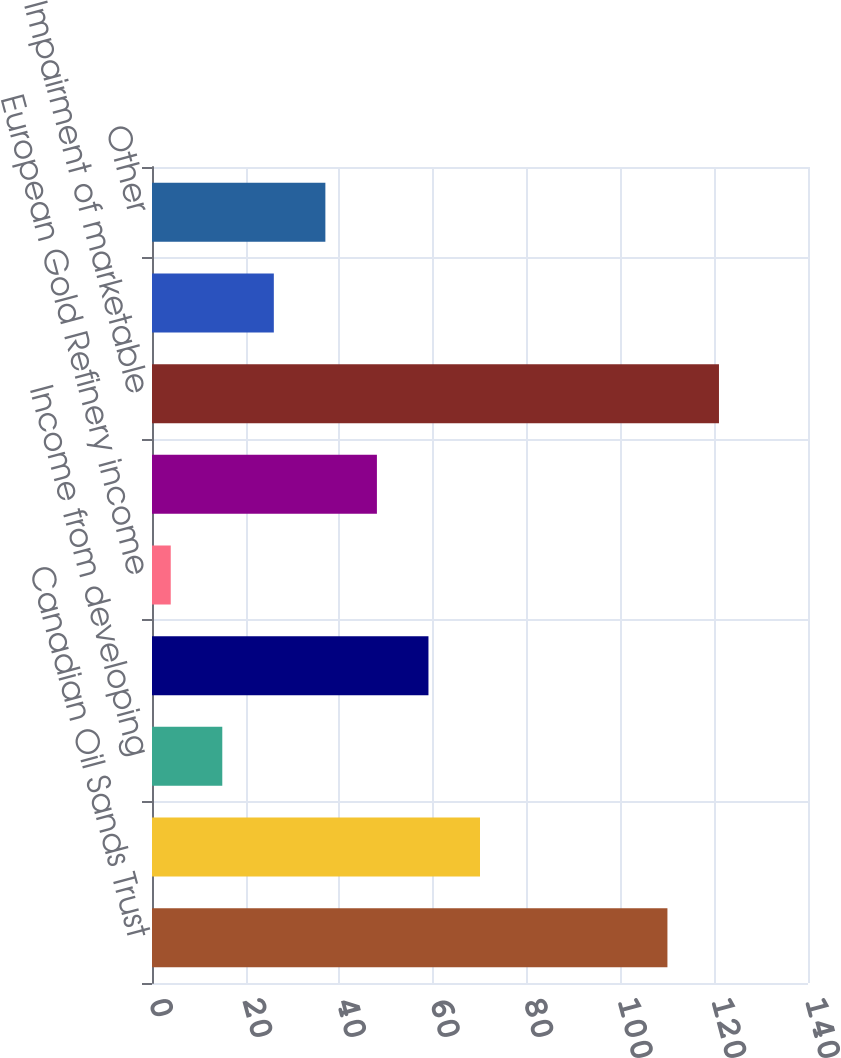Convert chart. <chart><loc_0><loc_0><loc_500><loc_500><bar_chart><fcel>Canadian Oil Sands Trust<fcel>Gain on asset sales net<fcel>Income from developing<fcel>Gain on sale of investments<fcel>European Gold Refinery income<fcel>Interest income<fcel>Impairment of marketable<fcel>Foreign currency exchange<fcel>Other<nl><fcel>110<fcel>70<fcel>15<fcel>59<fcel>4<fcel>48<fcel>121<fcel>26<fcel>37<nl></chart> 